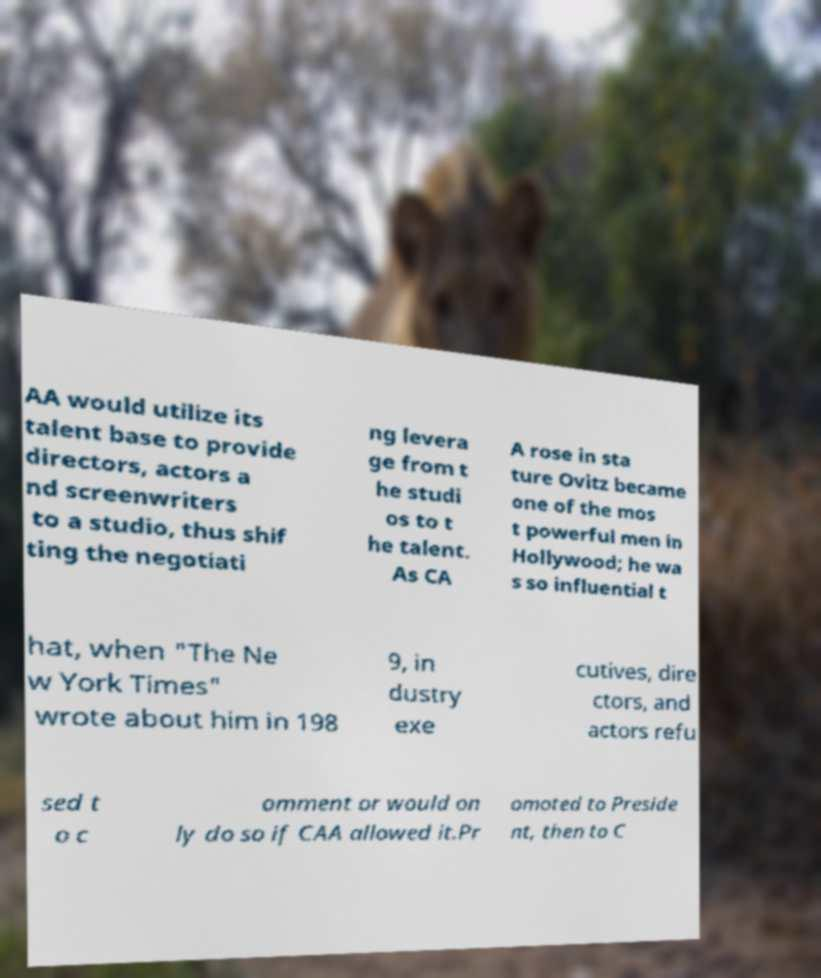I need the written content from this picture converted into text. Can you do that? AA would utilize its talent base to provide directors, actors a nd screenwriters to a studio, thus shif ting the negotiati ng levera ge from t he studi os to t he talent. As CA A rose in sta ture Ovitz became one of the mos t powerful men in Hollywood; he wa s so influential t hat, when "The Ne w York Times" wrote about him in 198 9, in dustry exe cutives, dire ctors, and actors refu sed t o c omment or would on ly do so if CAA allowed it.Pr omoted to Preside nt, then to C 